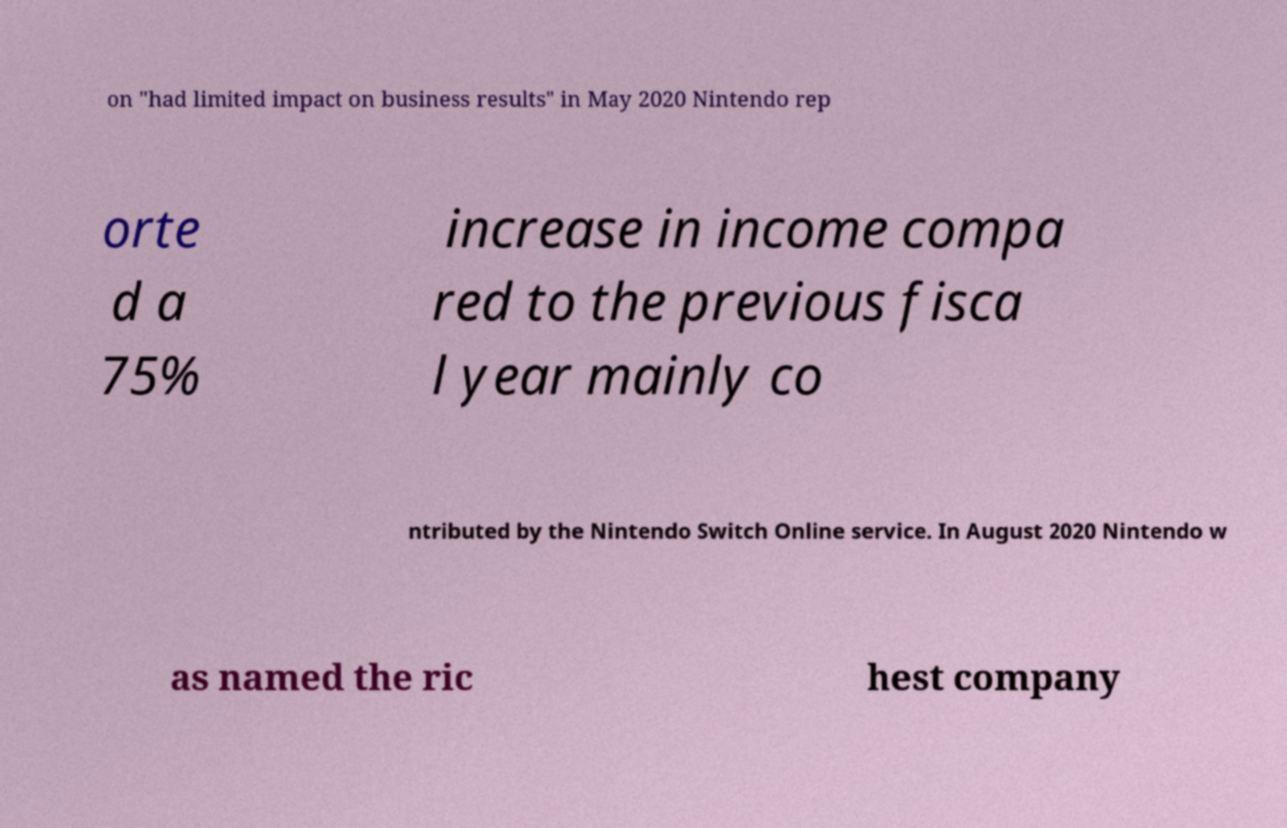I need the written content from this picture converted into text. Can you do that? on "had limited impact on business results" in May 2020 Nintendo rep orte d a 75% increase in income compa red to the previous fisca l year mainly co ntributed by the Nintendo Switch Online service. In August 2020 Nintendo w as named the ric hest company 